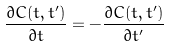Convert formula to latex. <formula><loc_0><loc_0><loc_500><loc_500>\frac { \partial C ( t , t ^ { \prime } ) } { \partial t } = - \frac { \partial C ( t , t ^ { \prime } ) } { \partial t ^ { \prime } }</formula> 